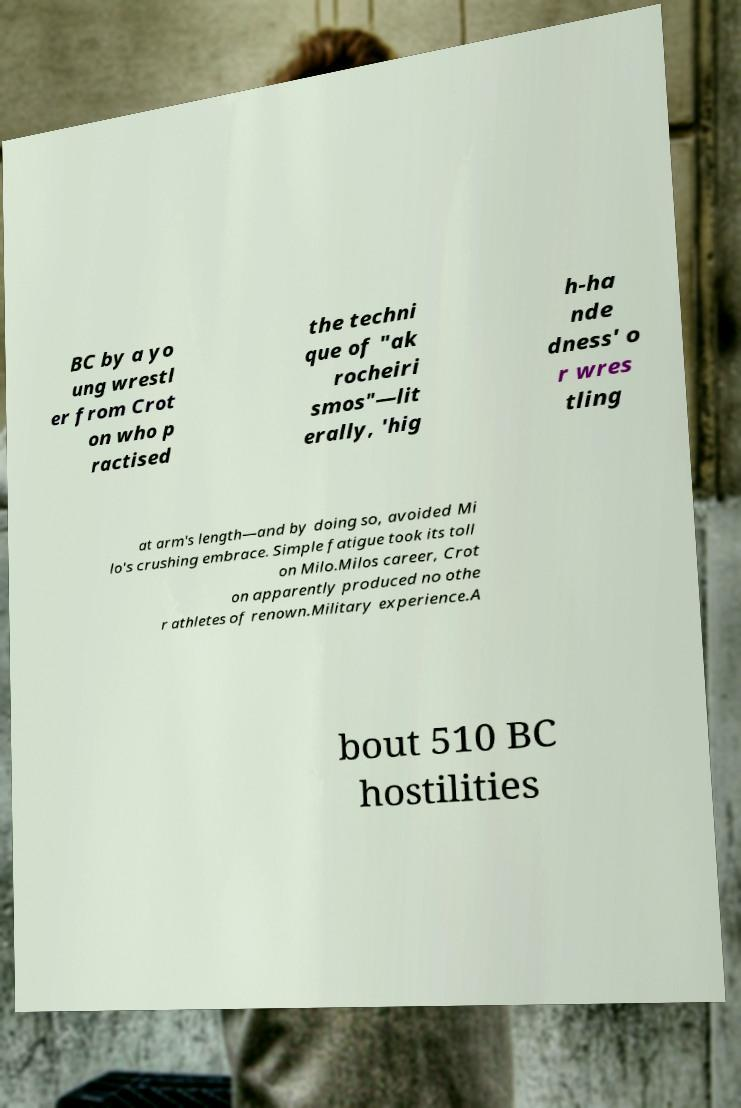What messages or text are displayed in this image? I need them in a readable, typed format. BC by a yo ung wrestl er from Crot on who p ractised the techni que of "ak rocheiri smos"—lit erally, 'hig h-ha nde dness' o r wres tling at arm's length—and by doing so, avoided Mi lo's crushing embrace. Simple fatigue took its toll on Milo.Milos career, Crot on apparently produced no othe r athletes of renown.Military experience.A bout 510 BC hostilities 